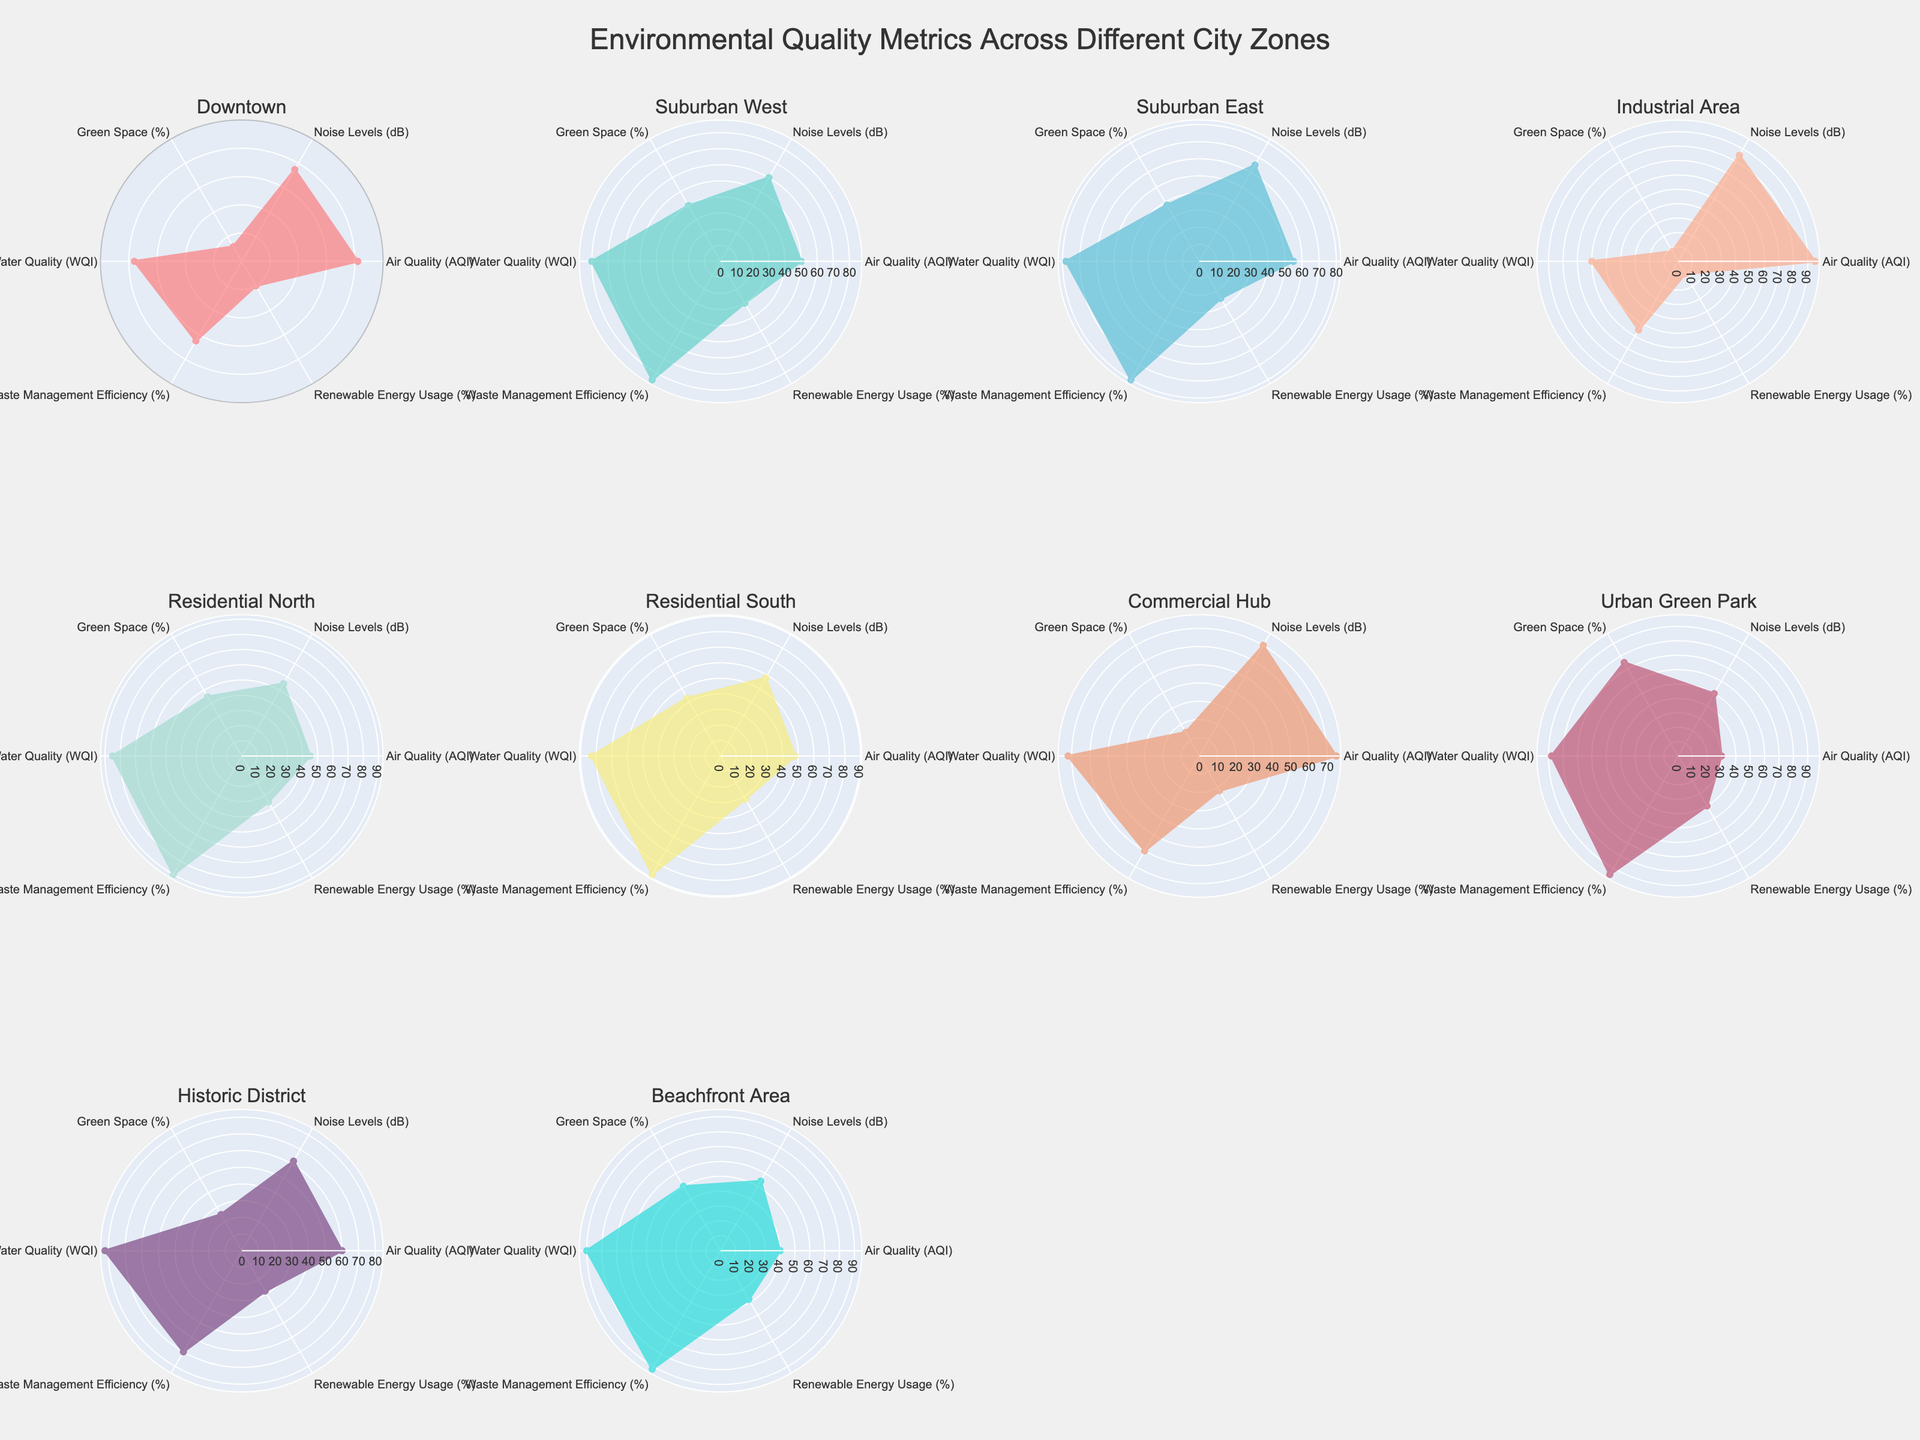How many city zones are displayed in the figure? To determine the number of city zones displayed, we count the subplots in the figure. Each subplot represents one city zone, and there are 10 subplots in total.
Answer: 10 Which city zone has the highest percentage of green space? Reviewing the subplot data, Urban Green Park shows a peak at the "Green Space (%)" axis, indicating it has the highest value.
Answer: Urban Green Park Which two city zones have the lowest air quality? By examining the subplots, the Downtown and Industrial Area plots have the highest Air Quality Index (AQI) values (which indicate poor air quality). Downtown is at 82, and Industrial Area is at 95.
Answer: Downtown, Industrial Area Compare Renewable Energy Usage (%) between Suburban West and Historic District. Which zone uses more? In the subplot for Renewable Energy Usage, Suburban West is at 30%, while Historic District is at 28%. Therefore, Suburban West uses more renewable energy.
Answer: Suburban West What's the general trend in Waste Management Efficiency (%) across all zones? By looking at the radar charts, most zones have Waste Management Efficiency values between 55% and 95%, except for Downtown and Industrial Area, which are considerably lower. This shows a general tendency toward high values of waste management efficiency in most zones.
Answer: Generally high Does any city zone have a perfect score in any environmental metric? None of the subplots reach the outermost edge of any metric. Therefore, no city zone has a perfect score in any environmental metric.
Answer: No Which city zone has the highest Water Quality Index (WQI)? Referring to the radar charts, Beachfront Area shows the highest value on the "Water Quality (WQI)" axis with a value of 90.
Answer: Beachfront Area How does the noise level in Residential North compare with that in Industrial Area? By examining the Noise Levels (dB) in the subplots, Residential North has a noise level of 55 dB, whereas Industrial Area has a noise level of 85 dB. The Industrial Area is noisier.
Answer: Industrial Area is noisier What is common between Suburban West and Residential North regarding their environmental metrics? Both Suburban West and Residential North show high values in Waste Management Efficiency (%) and Water Quality (WQI), plus a significant percentage of Green Space.
Answer: High in Waste Management Efficiency and Water Quality, significant Green Space Identify the city zone with the least renewable energy usage and describe its environmental metrics profile. Industrial Area has the least Renewable Energy Usage (%) at 10%. Its radar chart profile shows high Air Quality Index (AQI, meaning poor air quality), high Noise Levels, minimal Green Space, average Water Quality and Waste Management Efficiency, and minimal Renewable Energy.
Answer: Industrial Area: High AQI & noise, low green space & renewable energy, avg water and waste management 